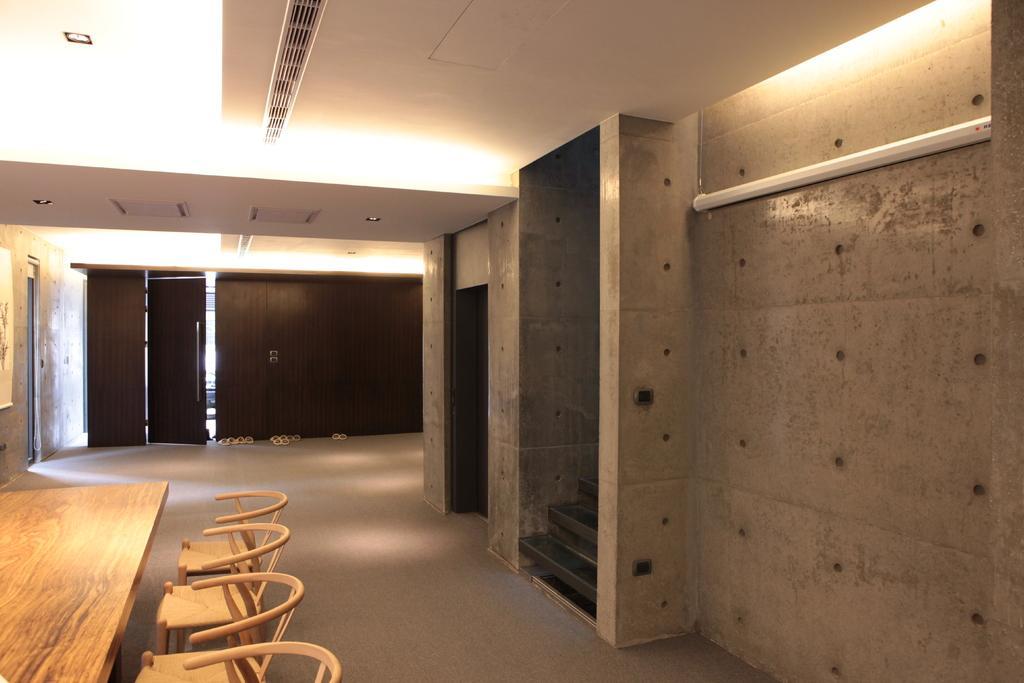Please provide a concise description of this image. This is a picture taken inside a room. On the left there are chairs and a table. On the right there are staircase and wall. On the top there are lights and grill. In the background there are sandals and a door. 